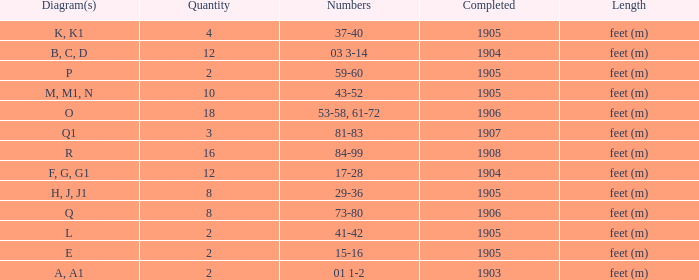For the item with more than 10, and numbers of 53-58, 61-72, what is the lowest completed? 1906.0. 